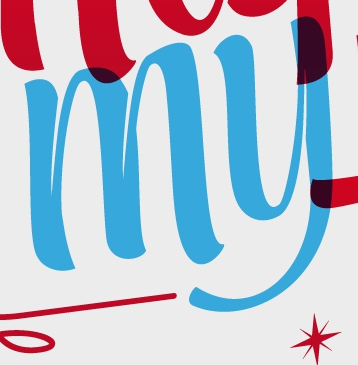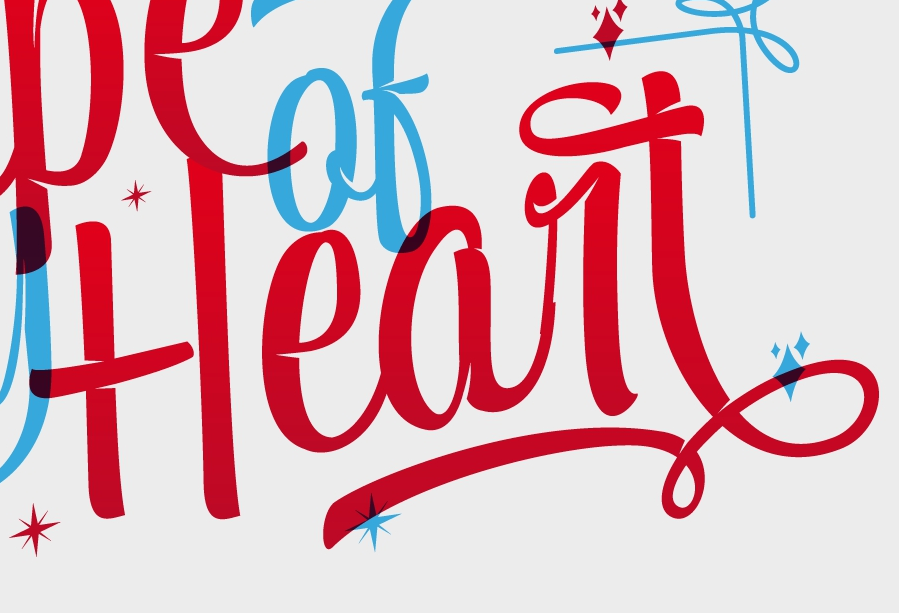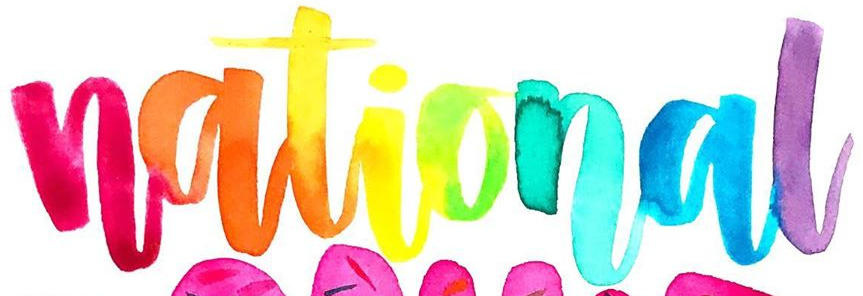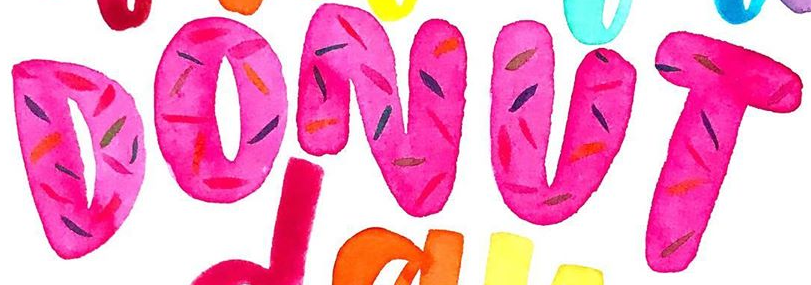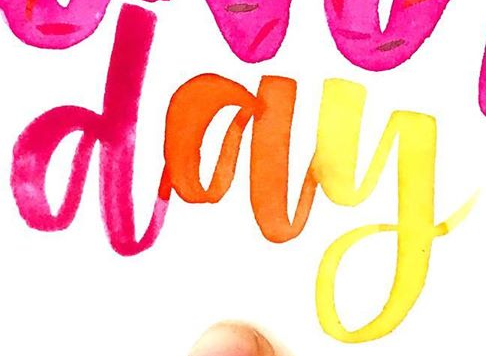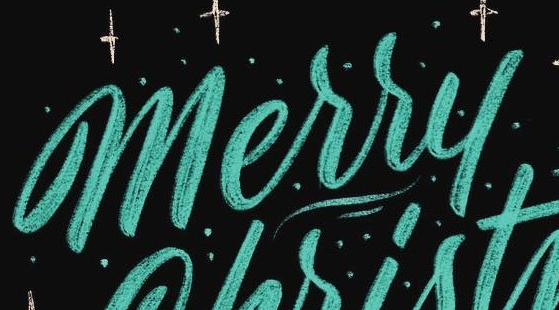Read the text from these images in sequence, separated by a semicolon. my; Heart; national; DONUT; day; Merry 